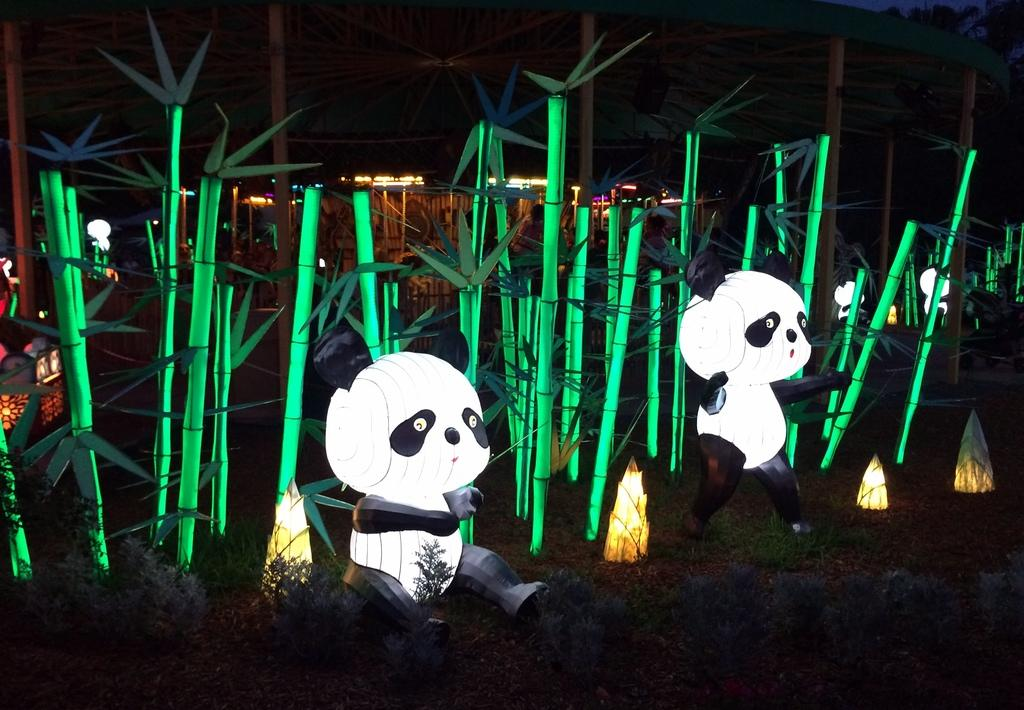What type of sticks are in the image? There are green sticks in the image. What animals are depicted in the image? There are depictions of pandas in the image. What other living organisms can be seen in the image? There are plants in the image. What type of illumination is present in the image? There are lights in the image, and lights can be seen far in the image. What is the animal's interest in the rod in the image? There is no animal or rod present in the image, so this question cannot be answered. 